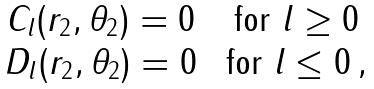<formula> <loc_0><loc_0><loc_500><loc_500>\begin{array} { c c } C _ { l } ( r _ { 2 } , \theta _ { 2 } ) = 0 & \text { for $l\geq0$} \\ D _ { l } ( r _ { 2 } , \theta _ { 2 } ) = 0 & \text { for $l\leq0$} \, , \\ \end{array}</formula> 